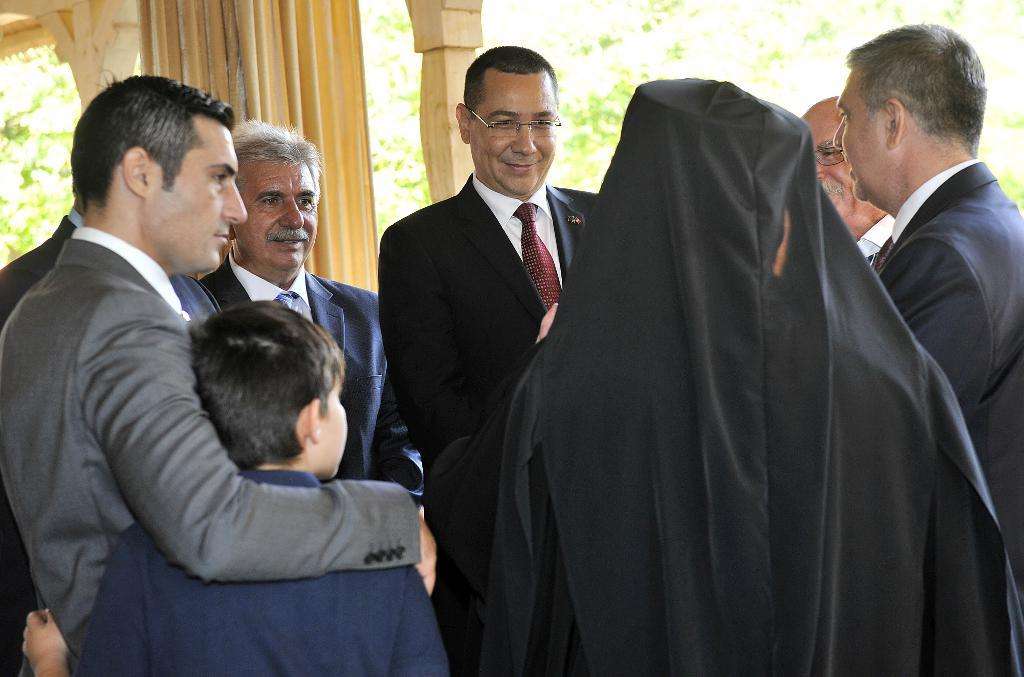What is located in the foreground of the image? There are people in the foreground of the image. What can be seen in the image that is related to interior design? There is a curtain in the image. What type of material is visible in the image? There are wooden poles in the image. What type of natural scenery is visible in the background of the image? There are trees in the background of the image. What type of suit is the person in the image wearing? There is no information about a suit in the image, as the facts provided do not mention any clothing. What is the temper of the trees in the background of the image? The temper of the trees cannot be determined, as trees do not have emotions. 